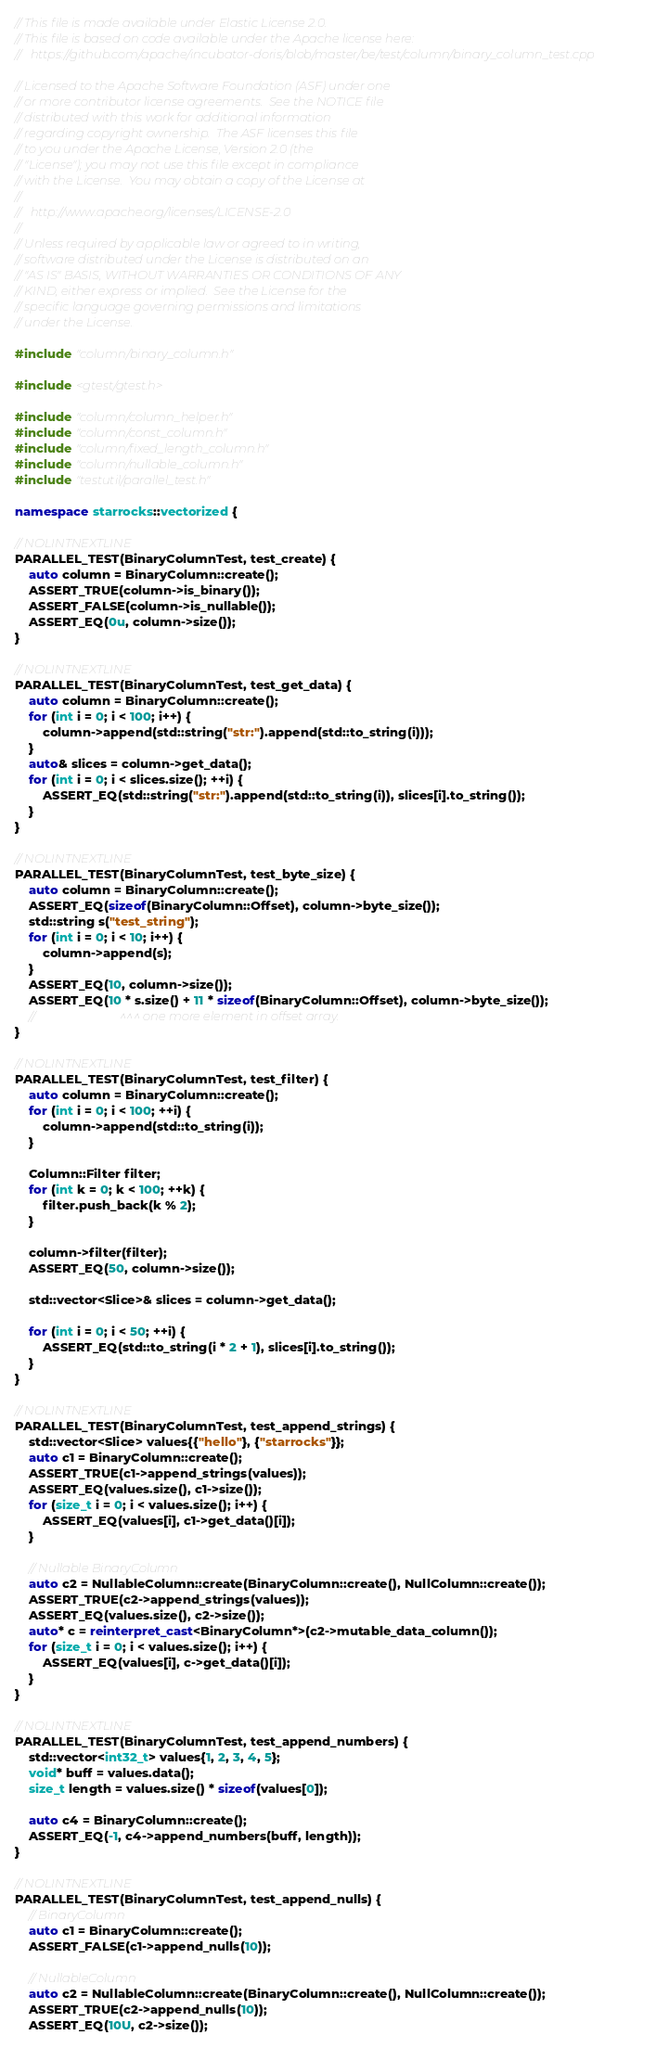Convert code to text. <code><loc_0><loc_0><loc_500><loc_500><_C++_>// This file is made available under Elastic License 2.0.
// This file is based on code available under the Apache license here:
//   https://github.com/apache/incubator-doris/blob/master/be/test/column/binary_column_test.cpp

// Licensed to the Apache Software Foundation (ASF) under one
// or more contributor license agreements.  See the NOTICE file
// distributed with this work for additional information
// regarding copyright ownership.  The ASF licenses this file
// to you under the Apache License, Version 2.0 (the
// "License"); you may not use this file except in compliance
// with the License.  You may obtain a copy of the License at
//
//   http://www.apache.org/licenses/LICENSE-2.0
//
// Unless required by applicable law or agreed to in writing,
// software distributed under the License is distributed on an
// "AS IS" BASIS, WITHOUT WARRANTIES OR CONDITIONS OF ANY
// KIND, either express or implied.  See the License for the
// specific language governing permissions and limitations
// under the License.

#include "column/binary_column.h"

#include <gtest/gtest.h>

#include "column/column_helper.h"
#include "column/const_column.h"
#include "column/fixed_length_column.h"
#include "column/nullable_column.h"
#include "testutil/parallel_test.h"

namespace starrocks::vectorized {

// NOLINTNEXTLINE
PARALLEL_TEST(BinaryColumnTest, test_create) {
    auto column = BinaryColumn::create();
    ASSERT_TRUE(column->is_binary());
    ASSERT_FALSE(column->is_nullable());
    ASSERT_EQ(0u, column->size());
}

// NOLINTNEXTLINE
PARALLEL_TEST(BinaryColumnTest, test_get_data) {
    auto column = BinaryColumn::create();
    for (int i = 0; i < 100; i++) {
        column->append(std::string("str:").append(std::to_string(i)));
    }
    auto& slices = column->get_data();
    for (int i = 0; i < slices.size(); ++i) {
        ASSERT_EQ(std::string("str:").append(std::to_string(i)), slices[i].to_string());
    }
}

// NOLINTNEXTLINE
PARALLEL_TEST(BinaryColumnTest, test_byte_size) {
    auto column = BinaryColumn::create();
    ASSERT_EQ(sizeof(BinaryColumn::Offset), column->byte_size());
    std::string s("test_string");
    for (int i = 0; i < 10; i++) {
        column->append(s);
    }
    ASSERT_EQ(10, column->size());
    ASSERT_EQ(10 * s.size() + 11 * sizeof(BinaryColumn::Offset), column->byte_size());
    //                            ^^^ one more element in offset array.
}

// NOLINTNEXTLINE
PARALLEL_TEST(BinaryColumnTest, test_filter) {
    auto column = BinaryColumn::create();
    for (int i = 0; i < 100; ++i) {
        column->append(std::to_string(i));
    }

    Column::Filter filter;
    for (int k = 0; k < 100; ++k) {
        filter.push_back(k % 2);
    }

    column->filter(filter);
    ASSERT_EQ(50, column->size());

    std::vector<Slice>& slices = column->get_data();

    for (int i = 0; i < 50; ++i) {
        ASSERT_EQ(std::to_string(i * 2 + 1), slices[i].to_string());
    }
}

// NOLINTNEXTLINE
PARALLEL_TEST(BinaryColumnTest, test_append_strings) {
    std::vector<Slice> values{{"hello"}, {"starrocks"}};
    auto c1 = BinaryColumn::create();
    ASSERT_TRUE(c1->append_strings(values));
    ASSERT_EQ(values.size(), c1->size());
    for (size_t i = 0; i < values.size(); i++) {
        ASSERT_EQ(values[i], c1->get_data()[i]);
    }

    // Nullable BinaryColumn
    auto c2 = NullableColumn::create(BinaryColumn::create(), NullColumn::create());
    ASSERT_TRUE(c2->append_strings(values));
    ASSERT_EQ(values.size(), c2->size());
    auto* c = reinterpret_cast<BinaryColumn*>(c2->mutable_data_column());
    for (size_t i = 0; i < values.size(); i++) {
        ASSERT_EQ(values[i], c->get_data()[i]);
    }
}

// NOLINTNEXTLINE
PARALLEL_TEST(BinaryColumnTest, test_append_numbers) {
    std::vector<int32_t> values{1, 2, 3, 4, 5};
    void* buff = values.data();
    size_t length = values.size() * sizeof(values[0]);

    auto c4 = BinaryColumn::create();
    ASSERT_EQ(-1, c4->append_numbers(buff, length));
}

// NOLINTNEXTLINE
PARALLEL_TEST(BinaryColumnTest, test_append_nulls) {
    // BinaryColumn
    auto c1 = BinaryColumn::create();
    ASSERT_FALSE(c1->append_nulls(10));

    // NullableColumn
    auto c2 = NullableColumn::create(BinaryColumn::create(), NullColumn::create());
    ASSERT_TRUE(c2->append_nulls(10));
    ASSERT_EQ(10U, c2->size());</code> 